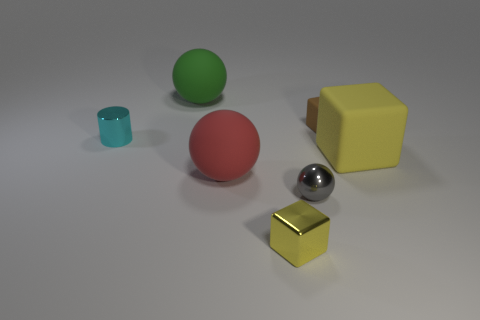Is the big red sphere made of the same material as the ball that is to the left of the big red matte sphere?
Offer a terse response. Yes. Is there another red object that has the same shape as the large red thing?
Provide a short and direct response. No. What material is the gray thing that is the same size as the brown rubber cube?
Your answer should be very brief. Metal. What is the size of the cube behind the large yellow block?
Offer a terse response. Small. Is the size of the rubber sphere left of the large red thing the same as the brown block right of the shiny cylinder?
Offer a terse response. No. What number of big yellow cubes are made of the same material as the big green ball?
Offer a terse response. 1. The big block has what color?
Your answer should be compact. Yellow. Are there any gray shiny things right of the small brown matte thing?
Offer a terse response. No. Is the color of the shiny block the same as the small ball?
Your response must be concise. No. What number of small matte things have the same color as the small shiny cylinder?
Give a very brief answer. 0. 